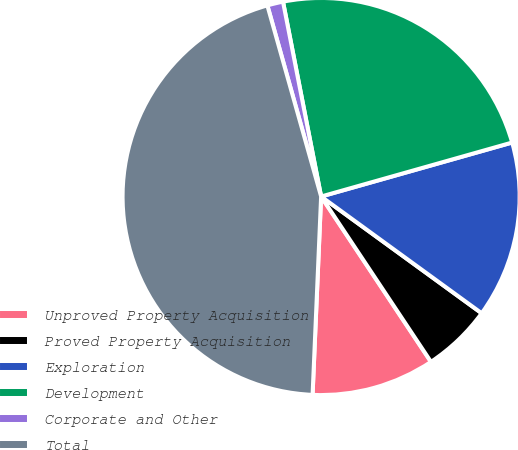<chart> <loc_0><loc_0><loc_500><loc_500><pie_chart><fcel>Unproved Property Acquisition<fcel>Proved Property Acquisition<fcel>Exploration<fcel>Development<fcel>Corporate and Other<fcel>Total<nl><fcel>10.02%<fcel>5.66%<fcel>14.39%<fcel>23.69%<fcel>1.29%<fcel>44.95%<nl></chart> 